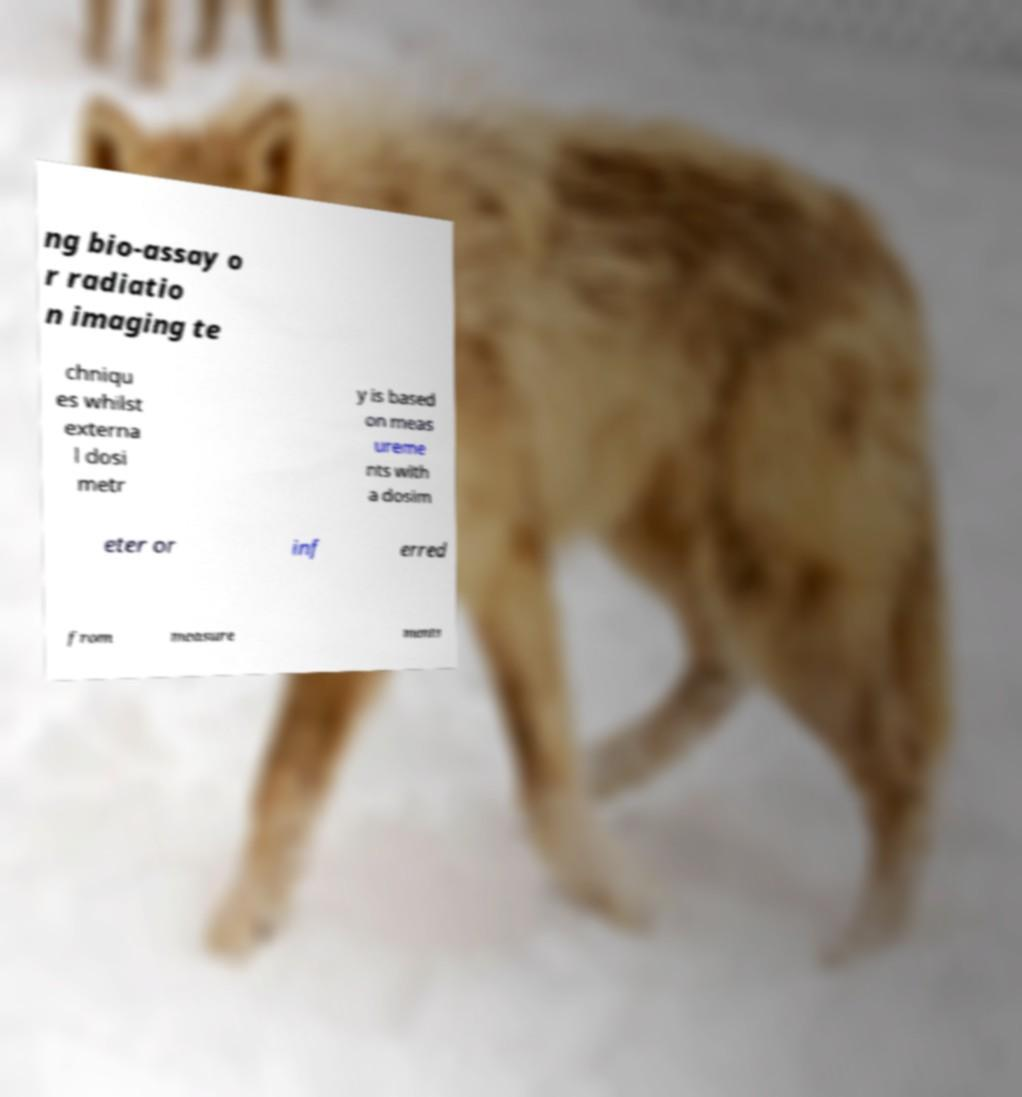Please read and relay the text visible in this image. What does it say? ng bio-assay o r radiatio n imaging te chniqu es whilst externa l dosi metr y is based on meas ureme nts with a dosim eter or inf erred from measure ments 